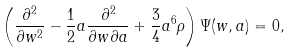<formula> <loc_0><loc_0><loc_500><loc_500>\left ( \frac { \partial ^ { 2 } } { \partial w ^ { 2 } } - \frac { 1 } { 2 } a \frac { \partial ^ { 2 } } { \partial w \partial a } + \frac { 3 } { 4 } a ^ { 6 } \rho \right ) \Psi ( w , a ) = 0 ,</formula> 